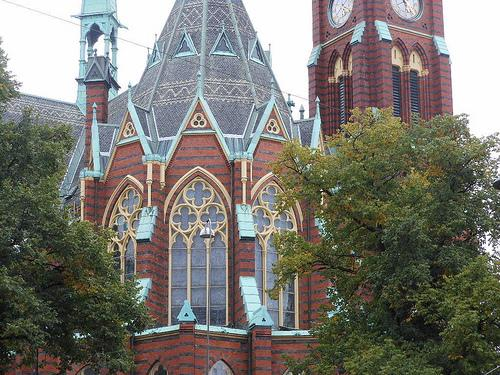List down the most noticeable features of the image, including both the building and the surroundings. Double sided clock tower, arched church windows, roof tower, light green trim, balcony, large green leafy trees, golden design on windows, and white sky. Summarize the main details of the image in one sentence. A red brick building with a double sided clock tower, arched windows, and a steep roof, surrounded by tall green trees and white sky. List three objects in the image and one characteristic of each. Double sided clock tower (white face), arched church window (golden design), and large green leafy tree (tall and in front of the building). Describe the key characteristics of the architecture in the image. The building features a red brick exterior, arched windows with golden design, a steep roof with light green trim, a double sided clock tower, and a tower on the roof. What are the different architectural elements and nature aspects visible in the image? Arched windows, double sided clock tower, steep roof, light green trim, golden window design, large green leafy trees, and white sky background. Provide a detailed description of the most prominent aspects of the image. A double sided clock tower with white face at the top of a red brick building, featuring arched windows with golden design, steep roof, and light green trim, surrounded by large green leafy trees. Describe the main elements of the building and its surroundings in the image. A red brick building featuring a double sided clock tower, arched windows with golden designs, a steep roof, and surrounded by large green leafy trees and a white sky. Write a concise description of the image, focusing on the main architectural elements. An image of a red brick building with arched windows, a double-sided clock tower, steep roof with light green trim, and surrounded by green trees. Mention the central object and secondary objects in the image. A double sided clock tower is the central object, with arched windows, roof tower, and multiple green leafy trees as secondary objects. Mention the prominent colors and elements seen in the image. Prominent colors: red bricks, light green trim, golden design on windows, and white sky. Elements: clock tower, arched windows, roof tower, and leafy trees. 